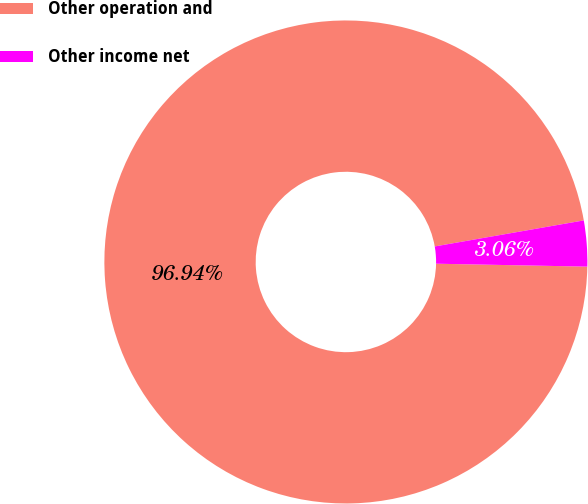Convert chart to OTSL. <chart><loc_0><loc_0><loc_500><loc_500><pie_chart><fcel>Other operation and<fcel>Other income net<nl><fcel>96.94%<fcel>3.06%<nl></chart> 